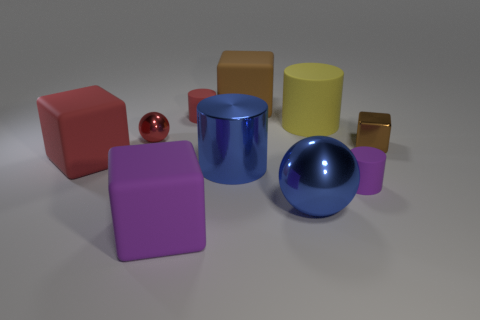Describe the lighting in the scene. Where is the light source coming from? The lighting in the scene is soft and diffuse, creating gentle shadows on the left sides of the objects, which implies that the light source is coming from the top right corner of the image frame. Does the scene appear to be indoors or outdoors? The scene appears to be indoors, as the lighting is controlled and there are no indicators of an outdoor environment, such as a sky or natural elements. 